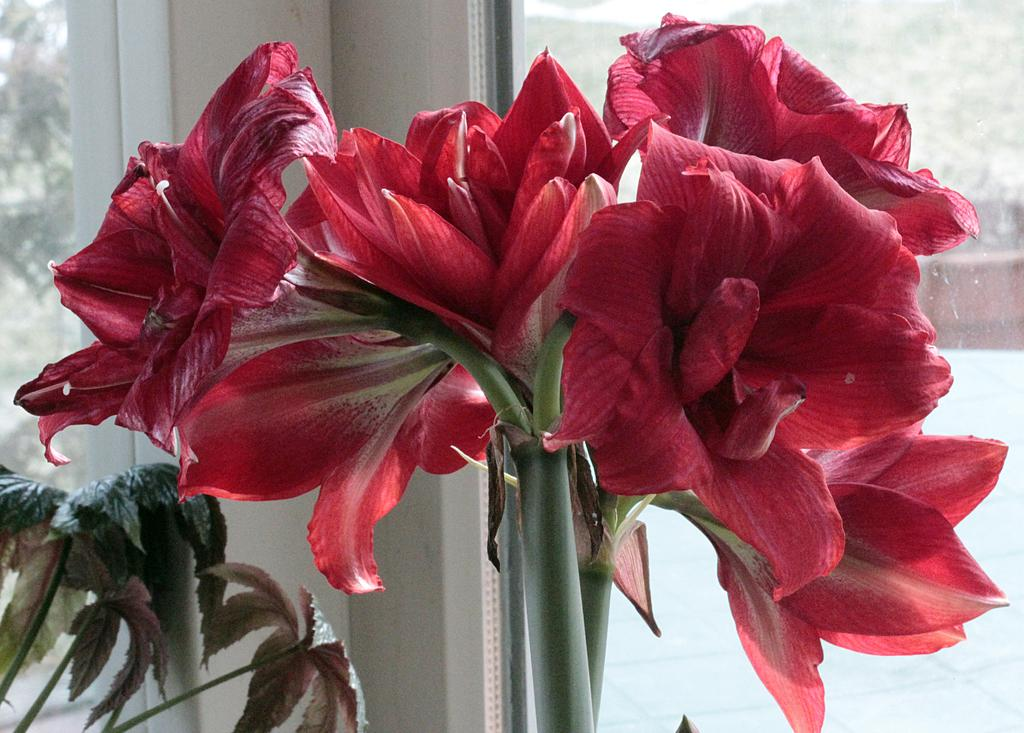What type of flowers can be seen in the image? There are red color flowers in the image. Where is the plant located in the image? The plant is on the left side of the image. What can be seen in the background of the image? There are trees in the background of the image. How many turkeys are visible in the image? There are no turkeys present in the image. What is the capacity of the hall in the image? There is no hall present in the image. 